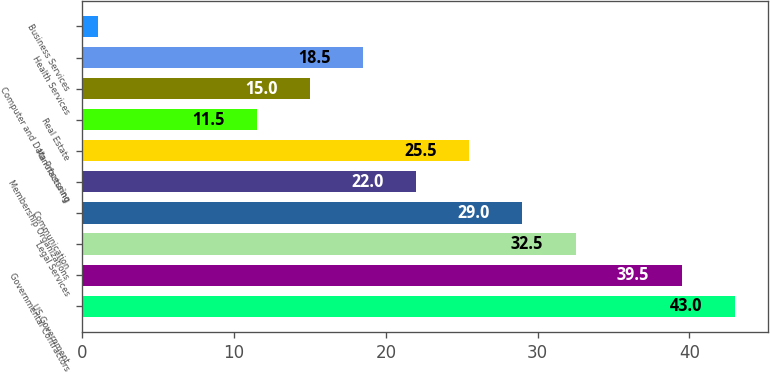<chart> <loc_0><loc_0><loc_500><loc_500><bar_chart><fcel>US Government<fcel>Governmental Contractors<fcel>Legal Services<fcel>Communication<fcel>Membership Organizations<fcel>Manufacturing<fcel>Real Estate<fcel>Computer and Data Processing<fcel>Health Services<fcel>Business Services<nl><fcel>43<fcel>39.5<fcel>32.5<fcel>29<fcel>22<fcel>25.5<fcel>11.5<fcel>15<fcel>18.5<fcel>1<nl></chart> 